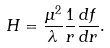<formula> <loc_0><loc_0><loc_500><loc_500>H = \frac { \mu ^ { 2 } } { \lambda } \frac { 1 } { r } \frac { d f } { d r } .</formula> 